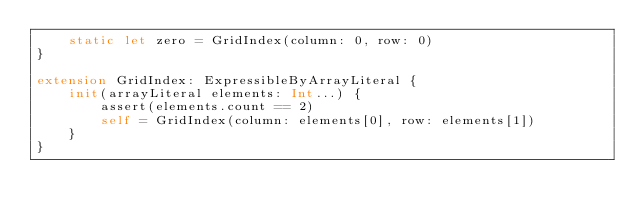<code> <loc_0><loc_0><loc_500><loc_500><_Swift_>    static let zero = GridIndex(column: 0, row: 0)
}

extension GridIndex: ExpressibleByArrayLiteral {
    init(arrayLiteral elements: Int...) {
        assert(elements.count == 2)
        self = GridIndex(column: elements[0], row: elements[1])
    }
}
</code> 